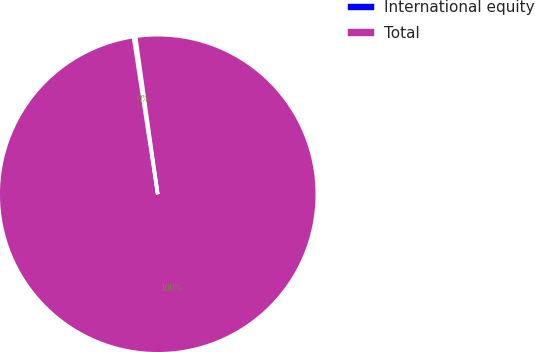Convert chart. <chart><loc_0><loc_0><loc_500><loc_500><pie_chart><fcel>International equity<fcel>Total<nl><fcel>0.22%<fcel>99.78%<nl></chart> 